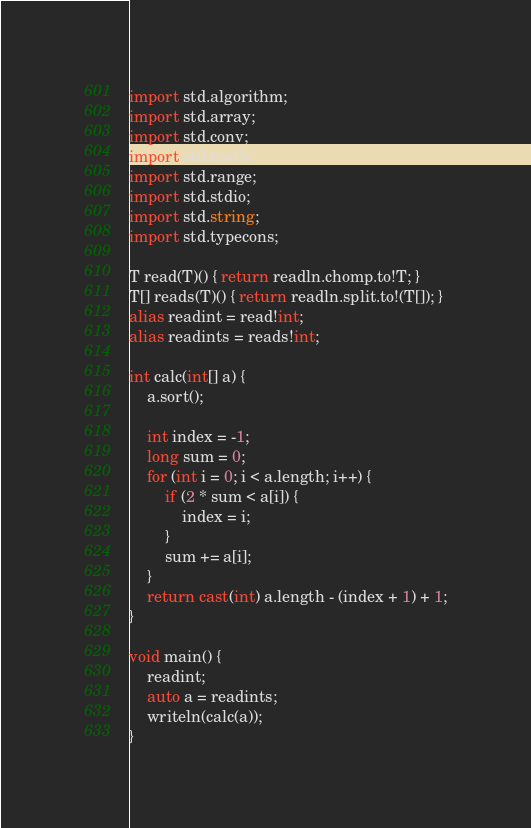Convert code to text. <code><loc_0><loc_0><loc_500><loc_500><_D_>import std.algorithm;
import std.array;
import std.conv;
import std.math;
import std.range;
import std.stdio;
import std.string;
import std.typecons;

T read(T)() { return readln.chomp.to!T; }
T[] reads(T)() { return readln.split.to!(T[]); }
alias readint = read!int;
alias readints = reads!int;

int calc(int[] a) {
    a.sort();

    int index = -1;
    long sum = 0;
    for (int i = 0; i < a.length; i++) {
        if (2 * sum < a[i]) {
            index = i;
        }
        sum += a[i];
    }
    return cast(int) a.length - (index + 1) + 1;
}

void main() {
    readint;
    auto a = readints;
    writeln(calc(a));
}
</code> 